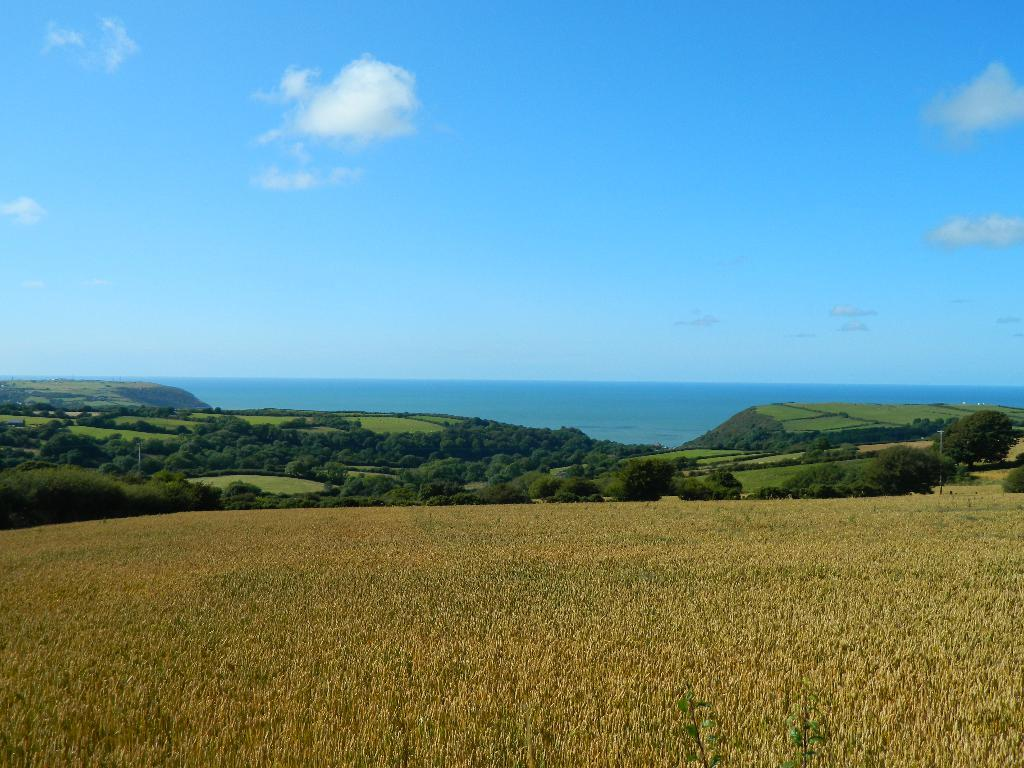What type of vegetation can be seen in the image? There is grass and trees visible in the image. What natural element is present in the image besides vegetation? There is water visible in the image. What can be seen in the background of the image? The sky is visible in the background of the image. Is there a ghost visible in the image? No, there is no ghost present in the image. What time of day is depicted in the image? The provided facts do not give information about the time of day, so it cannot be determined from the image. 